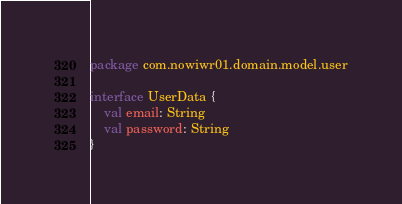Convert code to text. <code><loc_0><loc_0><loc_500><loc_500><_Kotlin_>package com.nowiwr01.domain.model.user

interface UserData {
    val email: String
    val password: String
}</code> 